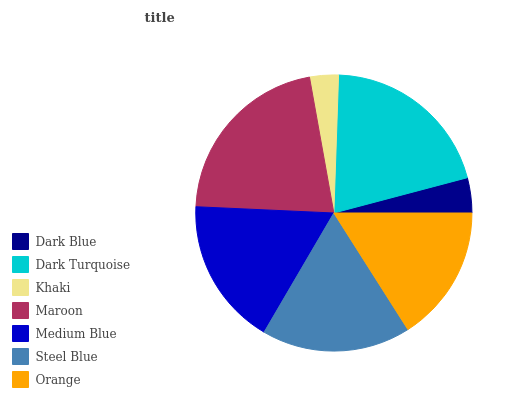Is Khaki the minimum?
Answer yes or no. Yes. Is Maroon the maximum?
Answer yes or no. Yes. Is Dark Turquoise the minimum?
Answer yes or no. No. Is Dark Turquoise the maximum?
Answer yes or no. No. Is Dark Turquoise greater than Dark Blue?
Answer yes or no. Yes. Is Dark Blue less than Dark Turquoise?
Answer yes or no. Yes. Is Dark Blue greater than Dark Turquoise?
Answer yes or no. No. Is Dark Turquoise less than Dark Blue?
Answer yes or no. No. Is Medium Blue the high median?
Answer yes or no. Yes. Is Medium Blue the low median?
Answer yes or no. Yes. Is Dark Turquoise the high median?
Answer yes or no. No. Is Steel Blue the low median?
Answer yes or no. No. 